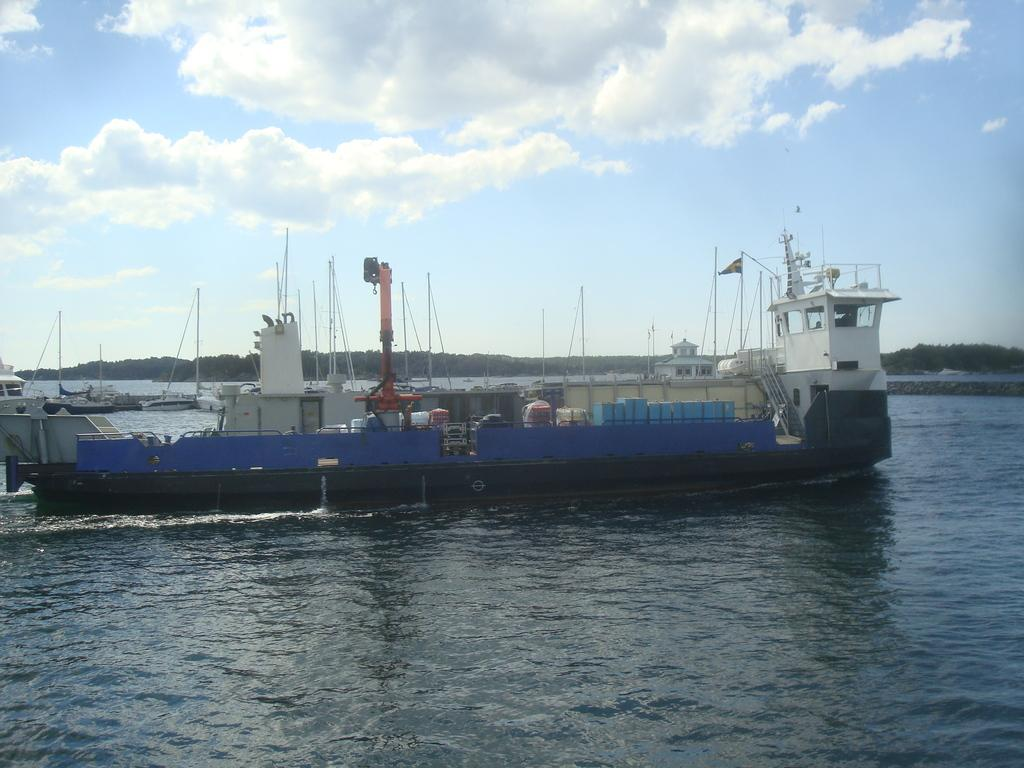What is the main subject of the image? The main subject of the image is water. What can be seen floating on the water? There are boats in the water. What type of vegetation is visible in the background of the image? There are trees in the background of the image. What is visible at the top of the image? The sky is visible at the top of the image. What can be seen in the sky? Clouds are present in the sky. What type of spark can be seen coming from the trees in the image? There is no spark present in the image; it features water, boats, trees, and clouds in the sky. 